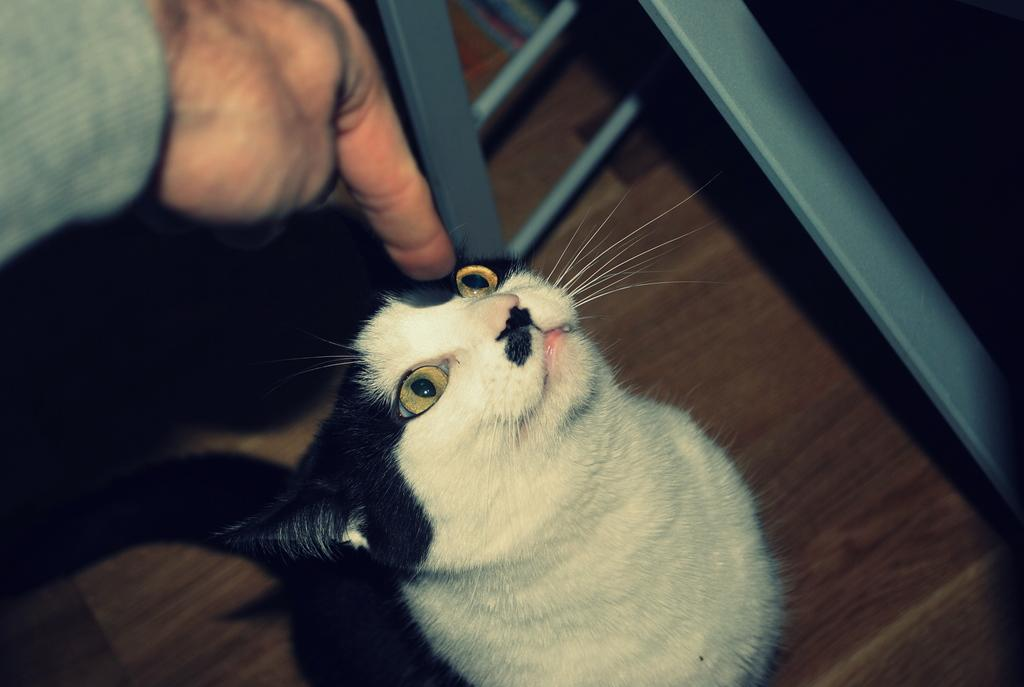What animal is present in the image? There is a cat in the image. What is the cat doing in the image? The cat is looking at a person in the image. Where is the cat located in the image? The cat is on the floor. Can you describe the person in the image? There is a person in the left corner of the image. What type of meat is the cat eating in the image? There is no meat present in the image; the cat is looking at a person. What color is the jelly that the cat is sitting on in the image? There is no jelly present in the image; the cat is on the floor. 